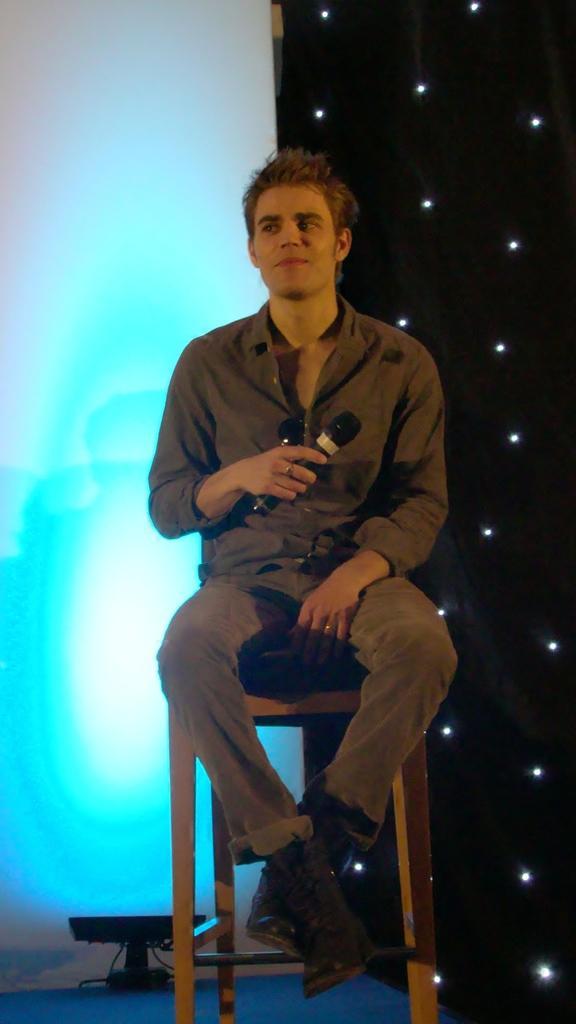Can you describe this image briefly? In this image we can see a man sitting on the seating stool and holding a mic in the hands. In the background there are decor lights. 